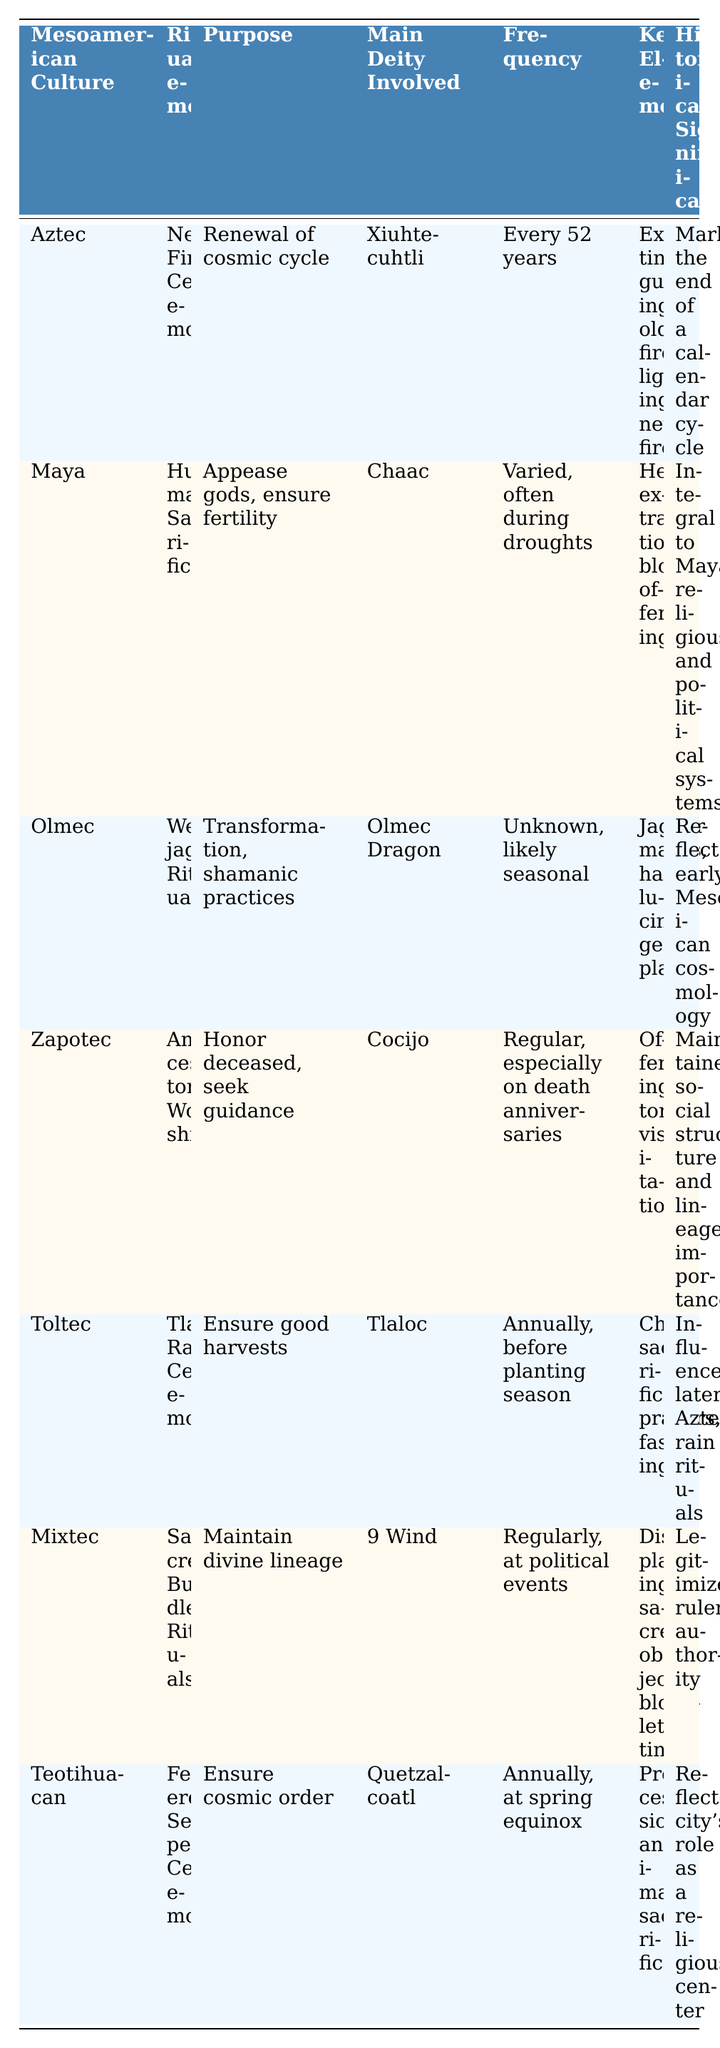What is the purpose of the New Fire Ceremony? The table indicates that the New Fire Ceremony's purpose is to renew the cosmic cycle.
Answer: Renewal of cosmic cycle Which Mesoamerican culture practiced human sacrifice? The table specifies that the Maya practiced human sacrifice.
Answer: Maya How often is the Tlaloc Rain Ceremony performed? According to the table, the Tlaloc Rain Ceremony is performed annually, before the planting season.
Answer: Annually What is the main deity involved in Ancestor Worship? The table shows that the main deity involved in Ancestor Worship is Cocijo.
Answer: Cocijo True or False: The Were-jaguar Ritual is associated with the deity Xiuhtecuhtli. Based on the table, the Were-jaguar Ritual is associated with the Olmec Dragon, not Xiuhtecuhtli.
Answer: False Which ritual involves child sacrifice? The Tlaloc Rain Ceremony involves child sacrifice, as listed in the table.
Answer: Tlaloc Rain Ceremony What are the key elements of the Feathered Serpent Ceremony? The table lists processions and animal sacrifices as the key elements of the Feathered Serpent Ceremony.
Answer: Processions, animal sacrifices How many Mesoamerican cultures have ceremonies related to agricultural purposes? The table mentions two ceremonies related to agriculture: Tlaloc Rain Ceremony and one other (could be inferred from context but only Tlaloc is explicit). Therefore, with the clarity provided, it stands at one.
Answer: One Which culture's ritual was integral to its political system? The table states that human sacrifice was integral to the Maya religious and political systems.
Answer: Maya What is the historical significance of the New Fire Ceremony? The table indicates that the New Fire Ceremony marked the end of a calendar cycle, highlighting its historical significance.
Answer: Marked the end of a calendar cycle What do Jaguar masks and hallucinogenic plants signify in Olmec rituals? The table outlines that jaguar masks and hallucinogenic plants are key elements in the Were-jaguar Ritual, signifying transformation and shamanic practices in Olmec culture.
Answer: Transformation, shamanic practices 